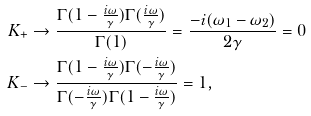Convert formula to latex. <formula><loc_0><loc_0><loc_500><loc_500>K _ { + } & \to \frac { \Gamma ( 1 - \frac { i \omega } { \gamma } ) \Gamma ( \frac { i \omega } { \gamma } ) } { \Gamma ( 1 ) } = \frac { - i ( \omega _ { 1 } - \omega _ { 2 } ) } { 2 \gamma } = 0 \\ K _ { - } & \to \frac { \Gamma ( 1 - \frac { i \omega } { \gamma } ) \Gamma ( - \frac { i \omega } { \gamma } ) } { \Gamma ( - \frac { i \omega } { \gamma } ) \Gamma ( 1 - \frac { i \omega } { \gamma } ) } = 1 ,</formula> 